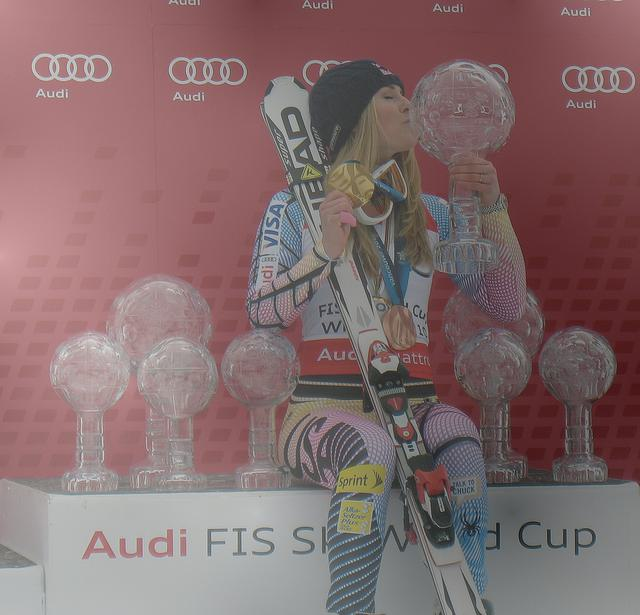Is the subject in the image clear and identifiable? Yes, the subject is clear and identifiable. The image displays a female athlete proudly kissing a medal, presumably celebrating her victory. She is surrounded by trophies and stands in front of a backdrop that includes the Audi and FIS World Cup logos, suggesting that this is an event associated with a skiing competition. 